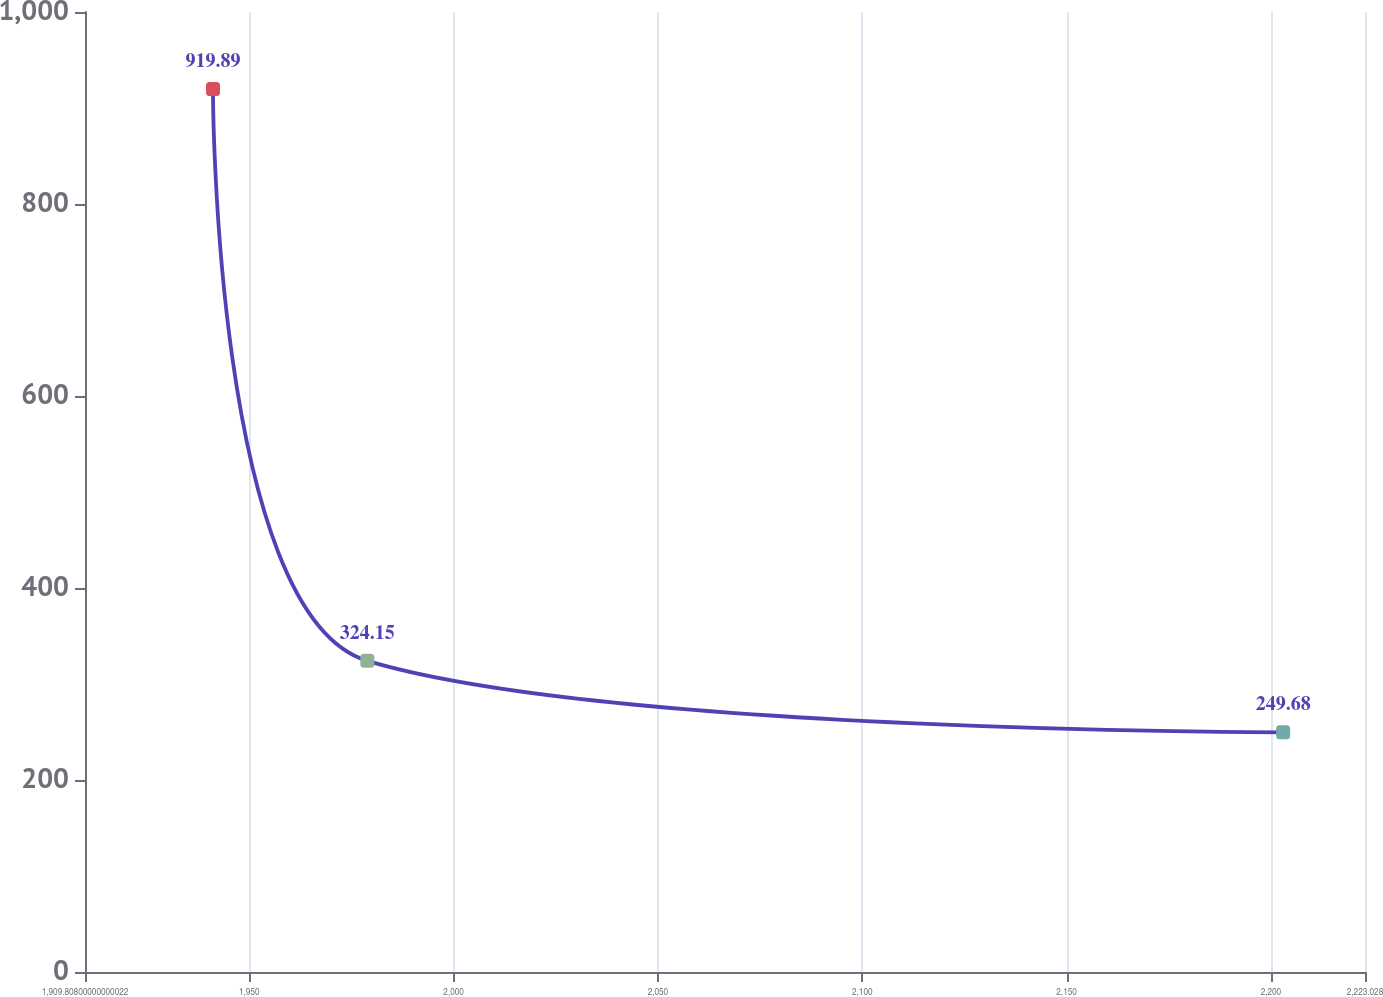<chart> <loc_0><loc_0><loc_500><loc_500><line_chart><ecel><fcel>$ 718<nl><fcel>1941.13<fcel>919.89<nl><fcel>1978.9<fcel>324.15<nl><fcel>2203<fcel>249.68<nl><fcel>2254.35<fcel>175.21<nl></chart> 